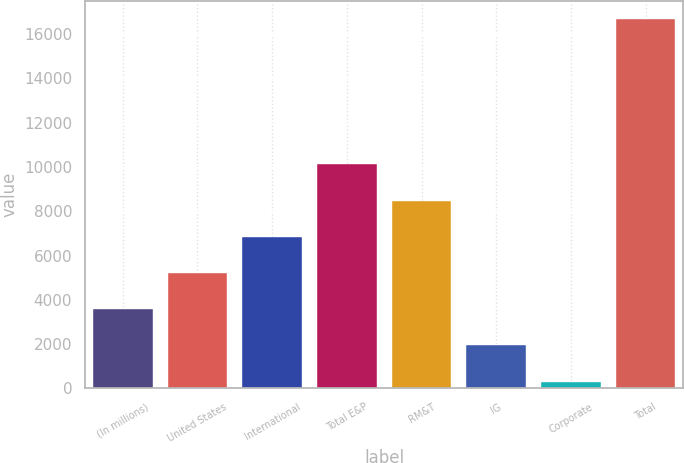Convert chart to OTSL. <chart><loc_0><loc_0><loc_500><loc_500><bar_chart><fcel>(In millions)<fcel>United States<fcel>International<fcel>Total E&P<fcel>RM&T<fcel>IG<fcel>Corporate<fcel>Total<nl><fcel>3577<fcel>5211.5<fcel>6846<fcel>10115<fcel>8480.5<fcel>1942.5<fcel>308<fcel>16653<nl></chart> 